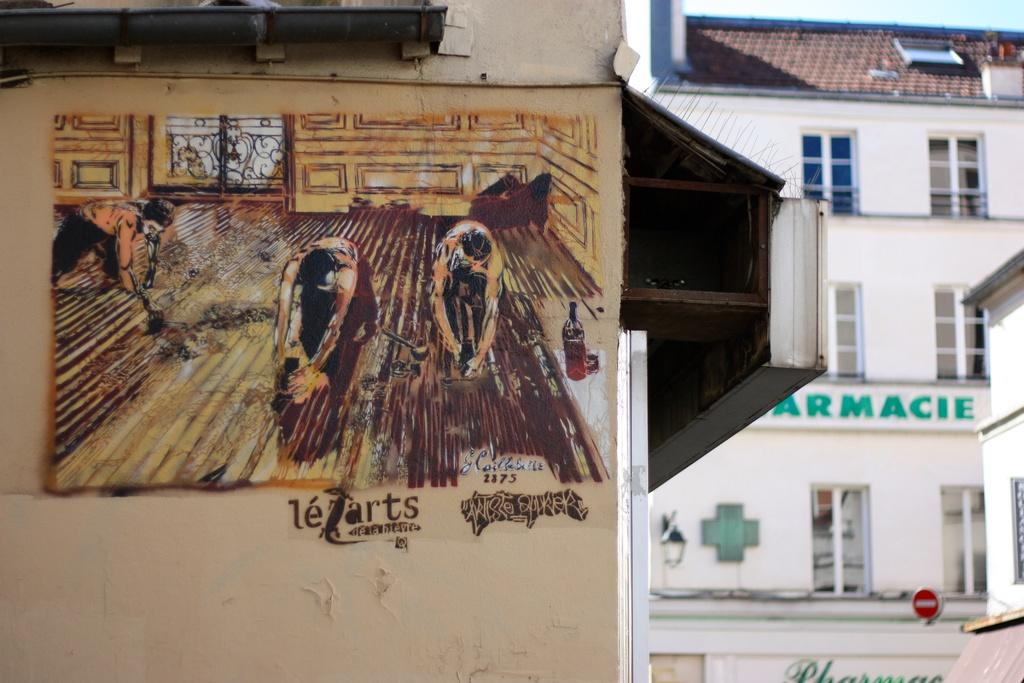What is depicted on the wall of a building in the image? There is a painting on the wall of a building in the image. What else can be seen in the image besides the painting? There are other buildings in the image, and they have windows. Is there any additional information provided by one of the buildings? Yes, there is a sign board on one of the buildings. Can you tell me how many times the word "quiver" appears on the sign board in the image? There is no mention of the word "quiver" on the sign board in the image. 